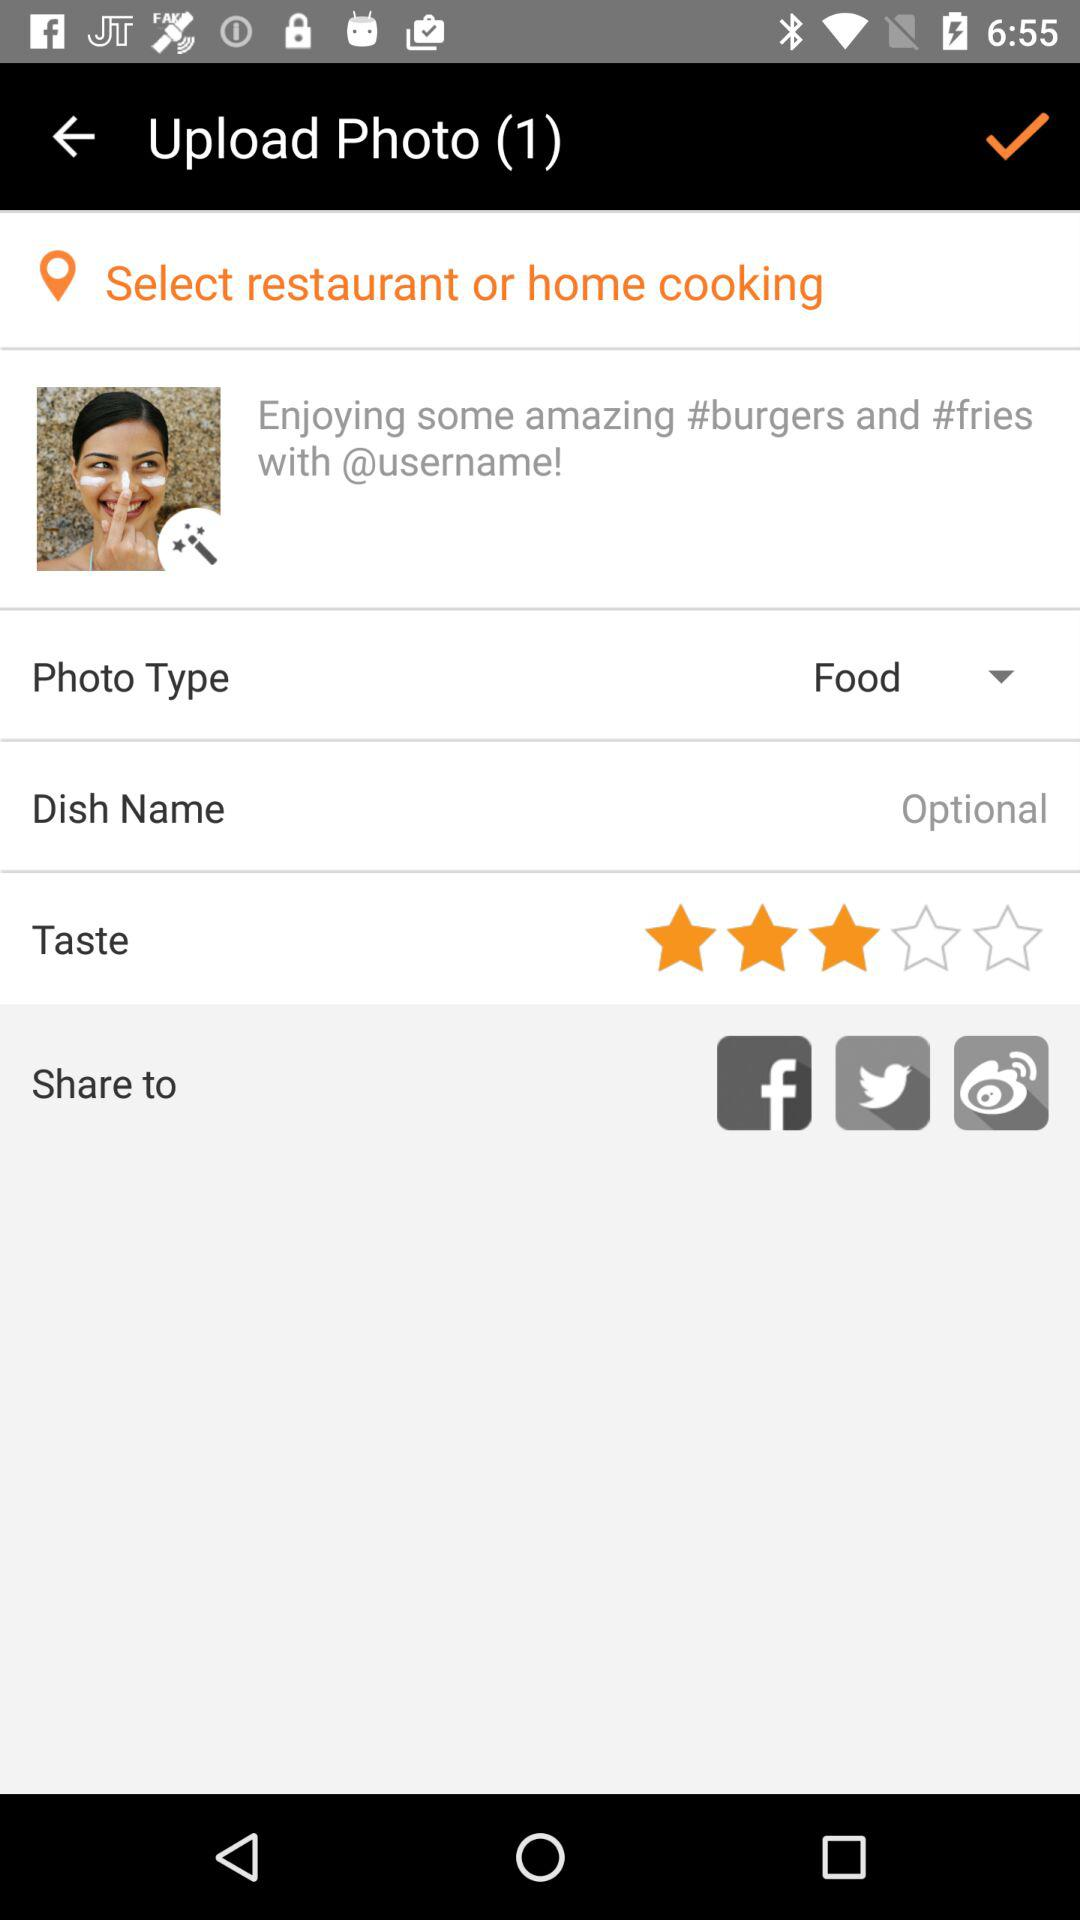How many social media options are there?
Answer the question using a single word or phrase. 3 